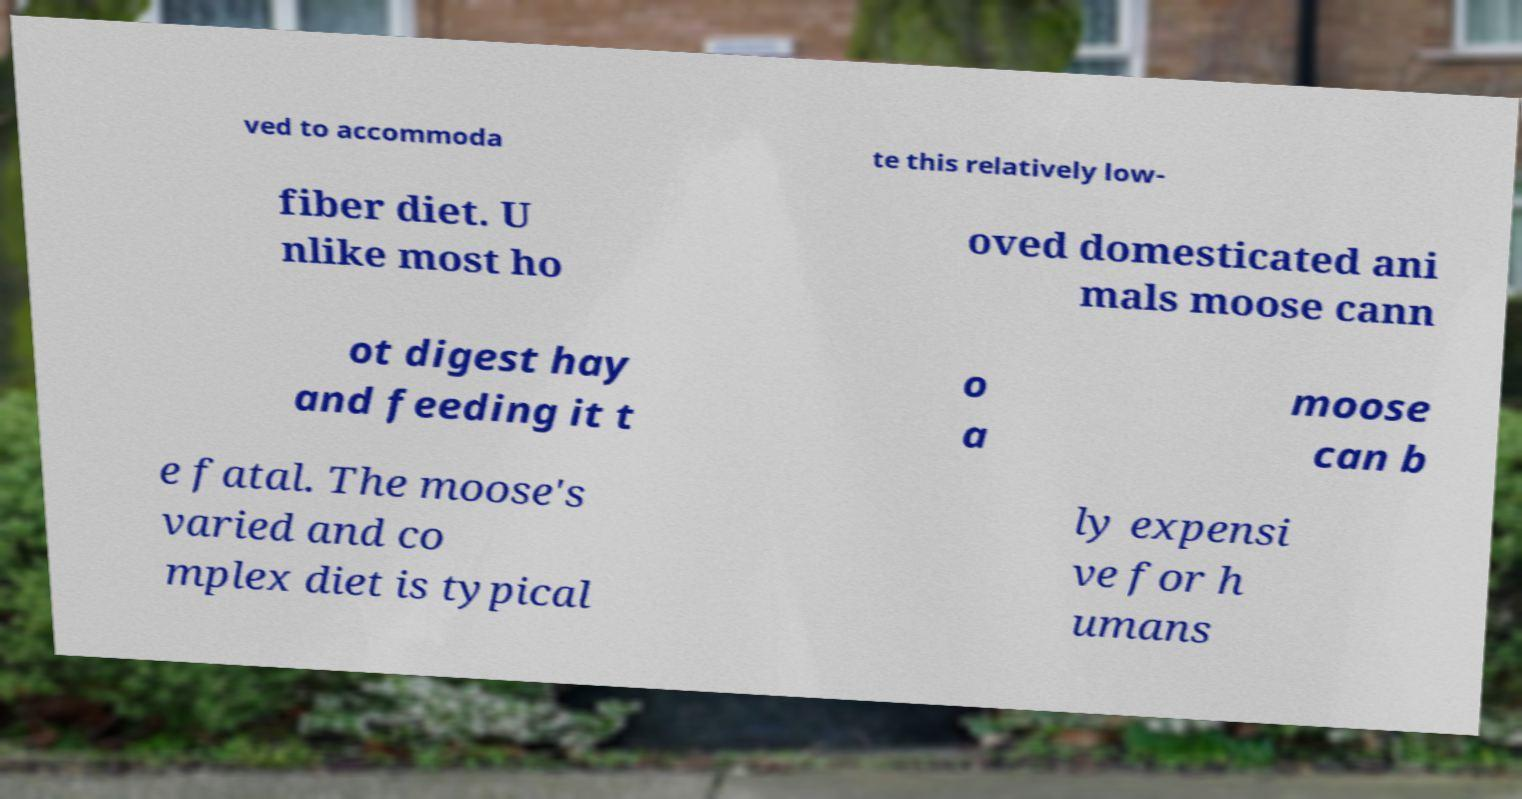Could you assist in decoding the text presented in this image and type it out clearly? ved to accommoda te this relatively low- fiber diet. U nlike most ho oved domesticated ani mals moose cann ot digest hay and feeding it t o a moose can b e fatal. The moose's varied and co mplex diet is typical ly expensi ve for h umans 